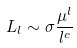<formula> <loc_0><loc_0><loc_500><loc_500>L _ { l } \sim \sigma \frac { \mu ^ { l } } { l ^ { c } }</formula> 